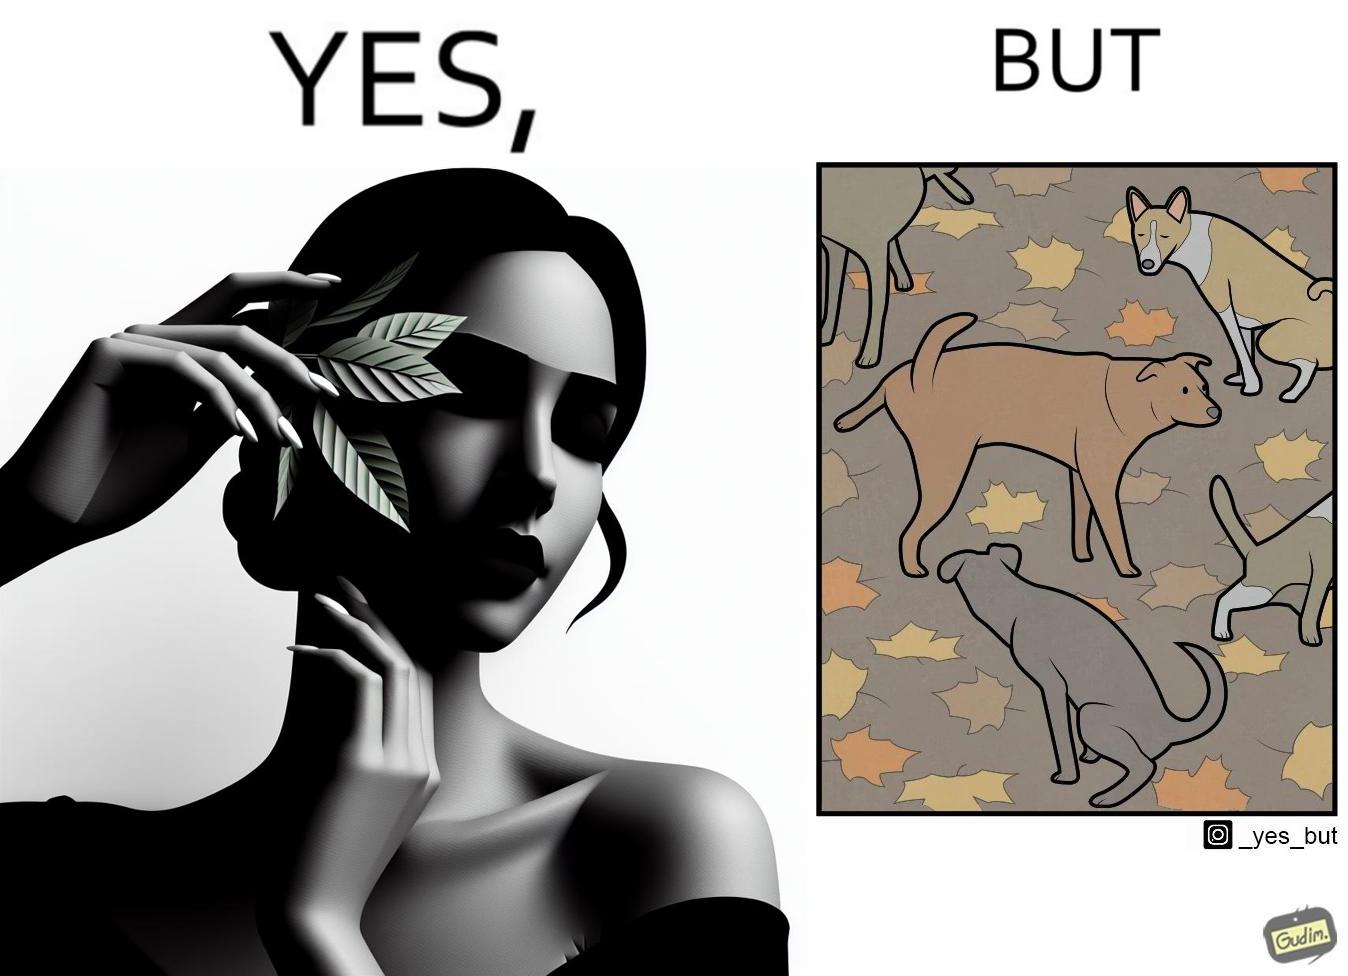Is this image satirical or non-satirical? Yes, this image is satirical. 